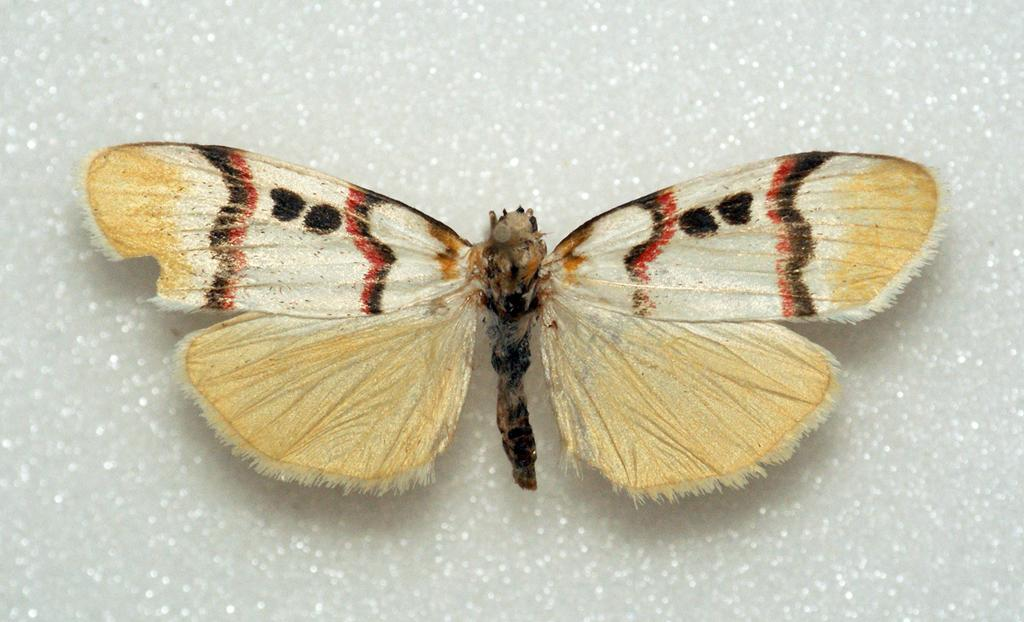What is the main subject of the picture? The main subject of the picture is a butterfly. Can you describe the colors of the butterfly? The butterfly has cream, red, and black colors. What other object is visible at the bottom of the picture? There is a marble at the bottom of the picture. What type of pear is being used as a prop in the picture? There is no pear present in the image; it features a butterfly and a marble. 